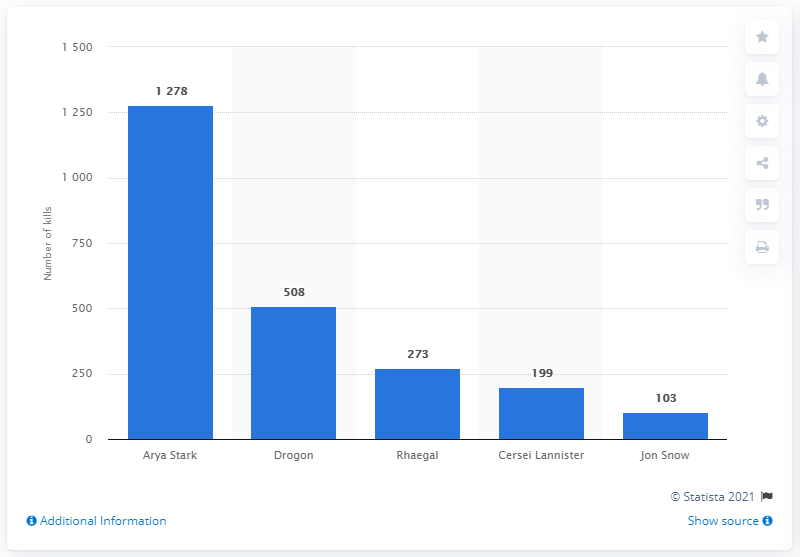Highlight a few significant elements in this photo. Game of Thrones' most lethal character was Arya Stark. Cersei Lannister, having accumulated nearly 200 kills, ranked fourth. 